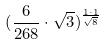<formula> <loc_0><loc_0><loc_500><loc_500>( \frac { 6 } { 2 6 8 } \cdot \sqrt { 3 } ) ^ { \frac { 1 \cdot 1 } { \sqrt { 8 } } }</formula> 